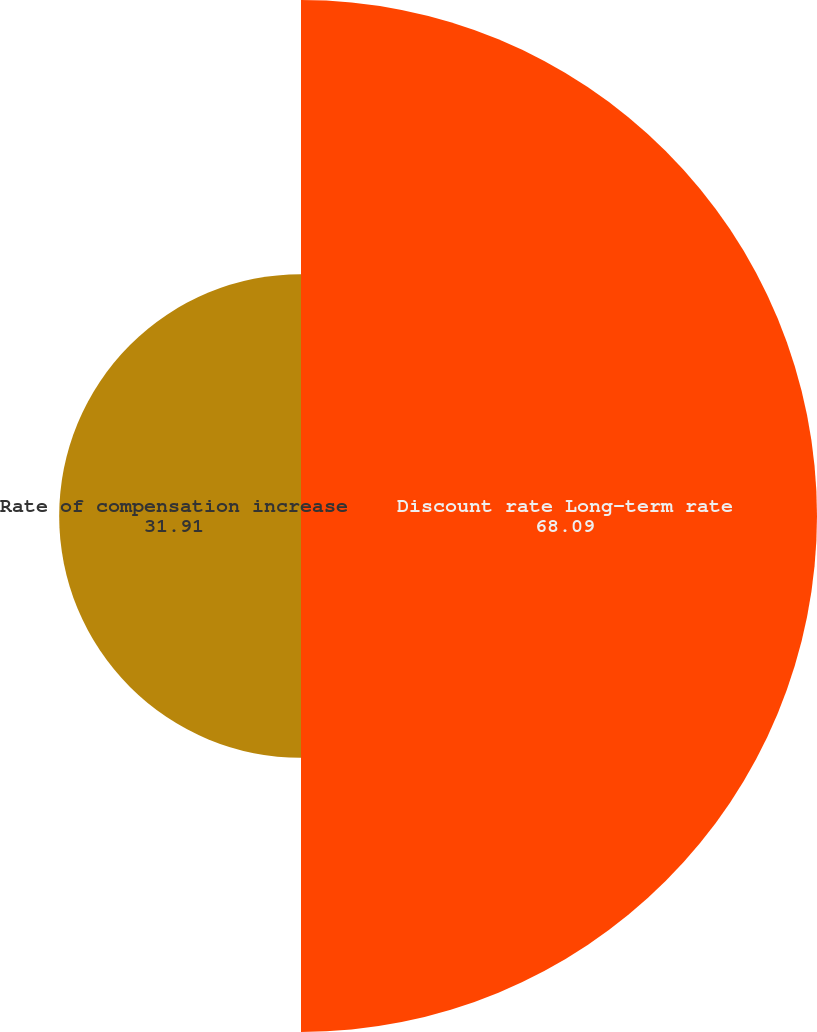<chart> <loc_0><loc_0><loc_500><loc_500><pie_chart><fcel>Discount rate Long-term rate<fcel>Rate of compensation increase<nl><fcel>68.09%<fcel>31.91%<nl></chart> 